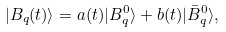<formula> <loc_0><loc_0><loc_500><loc_500>| B _ { q } ( t ) \rangle = a ( t ) | B ^ { 0 } _ { q } \rangle + b ( t ) | \bar { B } ^ { 0 } _ { q } \rangle ,</formula> 